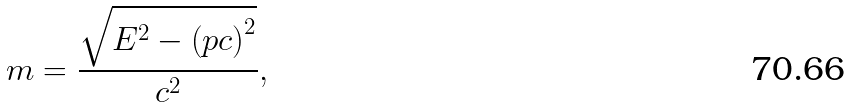Convert formula to latex. <formula><loc_0><loc_0><loc_500><loc_500>m = { \frac { \sqrt { E ^ { 2 } - \left ( p c \right ) ^ { 2 } } } { c ^ { 2 } } } ,</formula> 